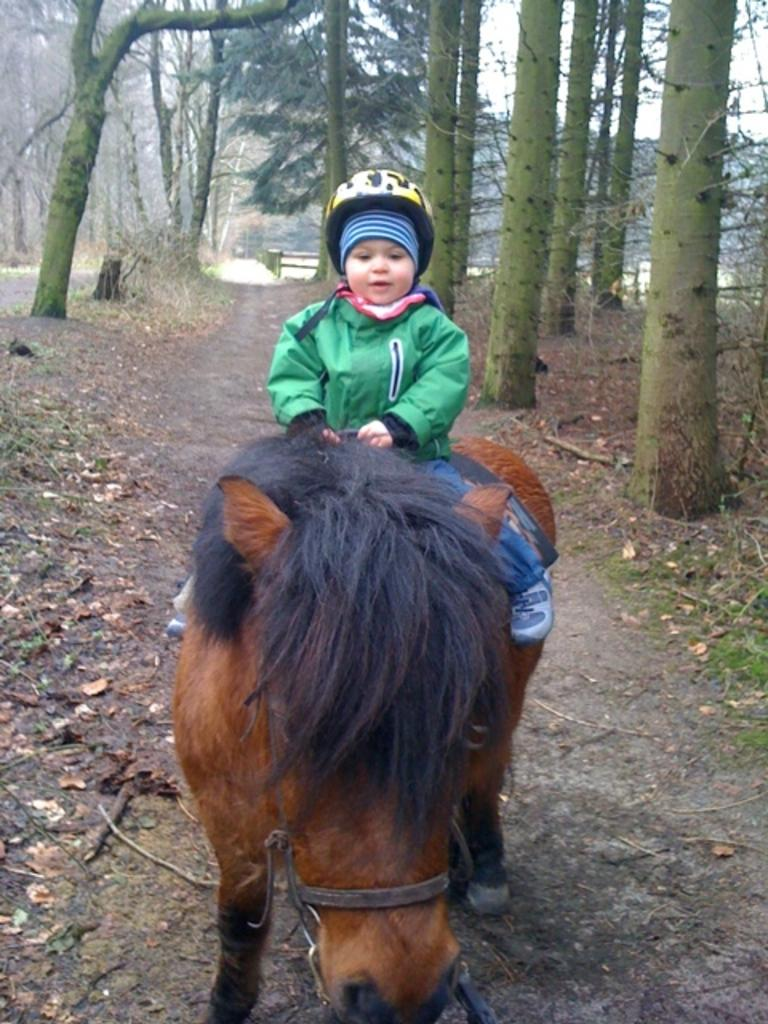What is the main subject of the image? The main subject of the image is a kid. What is the kid doing in the image? The kid is sitting on a horse. What type of clothing is the kid wearing? The kid is wearing a jacket and a helmet. What can be seen in the background of the image? There are trees in the distance. Is there a person standing next to the queen in the image? There is no queen or person standing next to her in the image; it features a kid sitting on a horse. 